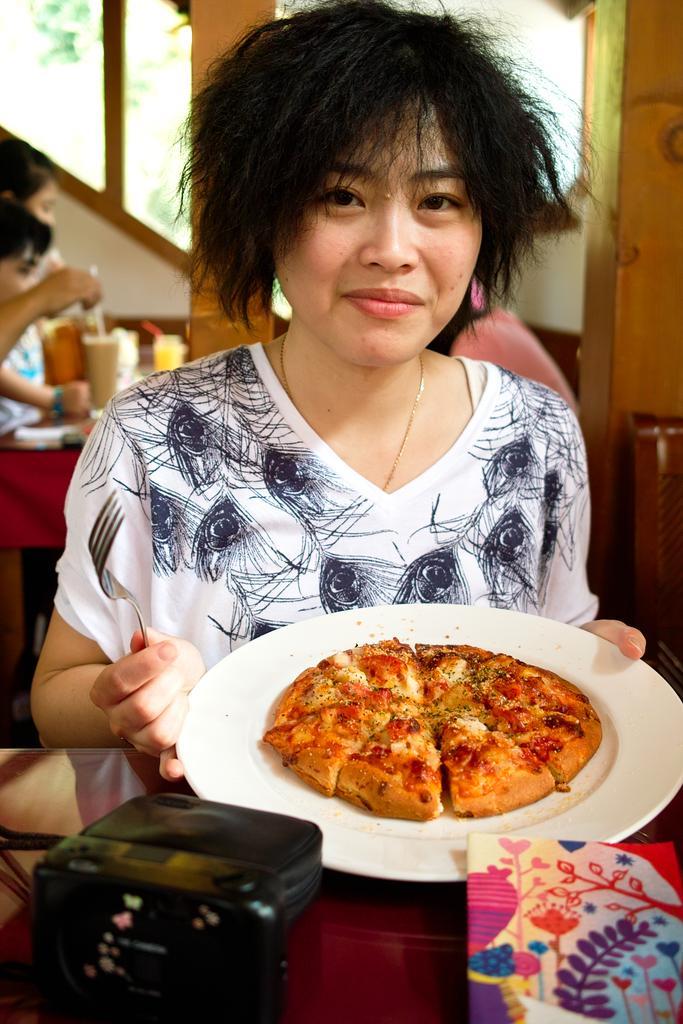Describe this image in one or two sentences. In this image we can see a woman smiling and holding the pizza plate. We can also see a black color object and a book on the wooden surface. In the background we can see the people in front of the table which is covered with the cloth. On the table we can see the glasses. In the background we can see the trees. 